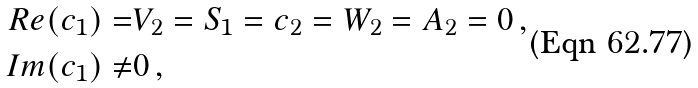Convert formula to latex. <formula><loc_0><loc_0><loc_500><loc_500>R e ( c _ { 1 } ) = & V _ { 2 } = S _ { 1 } = c _ { 2 } = W _ { 2 } = A _ { 2 } = 0 \, , \\ I m ( c _ { 1 } ) \neq & 0 \, ,</formula> 